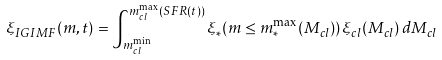Convert formula to latex. <formula><loc_0><loc_0><loc_500><loc_500>\xi _ { I G I M F } ( m , t ) = \int ^ { m ^ { \max } _ { c l } ( S F R ( t ) ) } _ { m ^ { \min } _ { c l } } \xi _ { \ast } ( m \leq m ^ { \max } _ { \ast } ( M _ { c l } ) ) \, \xi _ { c l } ( M _ { c l } ) \, d M _ { c l }</formula> 